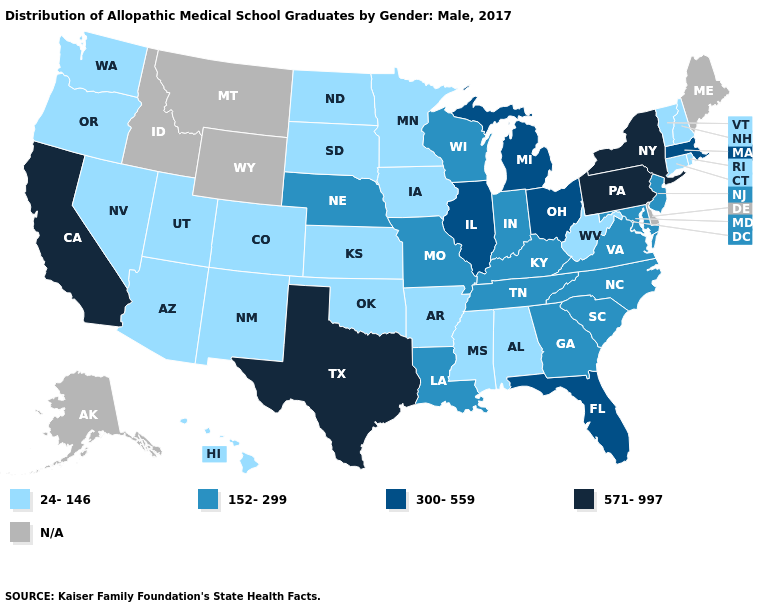Name the states that have a value in the range N/A?
Give a very brief answer. Alaska, Delaware, Idaho, Maine, Montana, Wyoming. Among the states that border New York , does Connecticut have the lowest value?
Give a very brief answer. Yes. Does New Jersey have the lowest value in the Northeast?
Be succinct. No. Does the map have missing data?
Concise answer only. Yes. Does the first symbol in the legend represent the smallest category?
Write a very short answer. Yes. Does Florida have the lowest value in the South?
Answer briefly. No. How many symbols are there in the legend?
Keep it brief. 5. What is the lowest value in states that border Nebraska?
Concise answer only. 24-146. What is the value of Alaska?
Keep it brief. N/A. Name the states that have a value in the range N/A?
Give a very brief answer. Alaska, Delaware, Idaho, Maine, Montana, Wyoming. Among the states that border Vermont , does Massachusetts have the highest value?
Keep it brief. No. Name the states that have a value in the range 571-997?
Give a very brief answer. California, New York, Pennsylvania, Texas. Which states have the highest value in the USA?
Keep it brief. California, New York, Pennsylvania, Texas. What is the value of Maine?
Be succinct. N/A. 